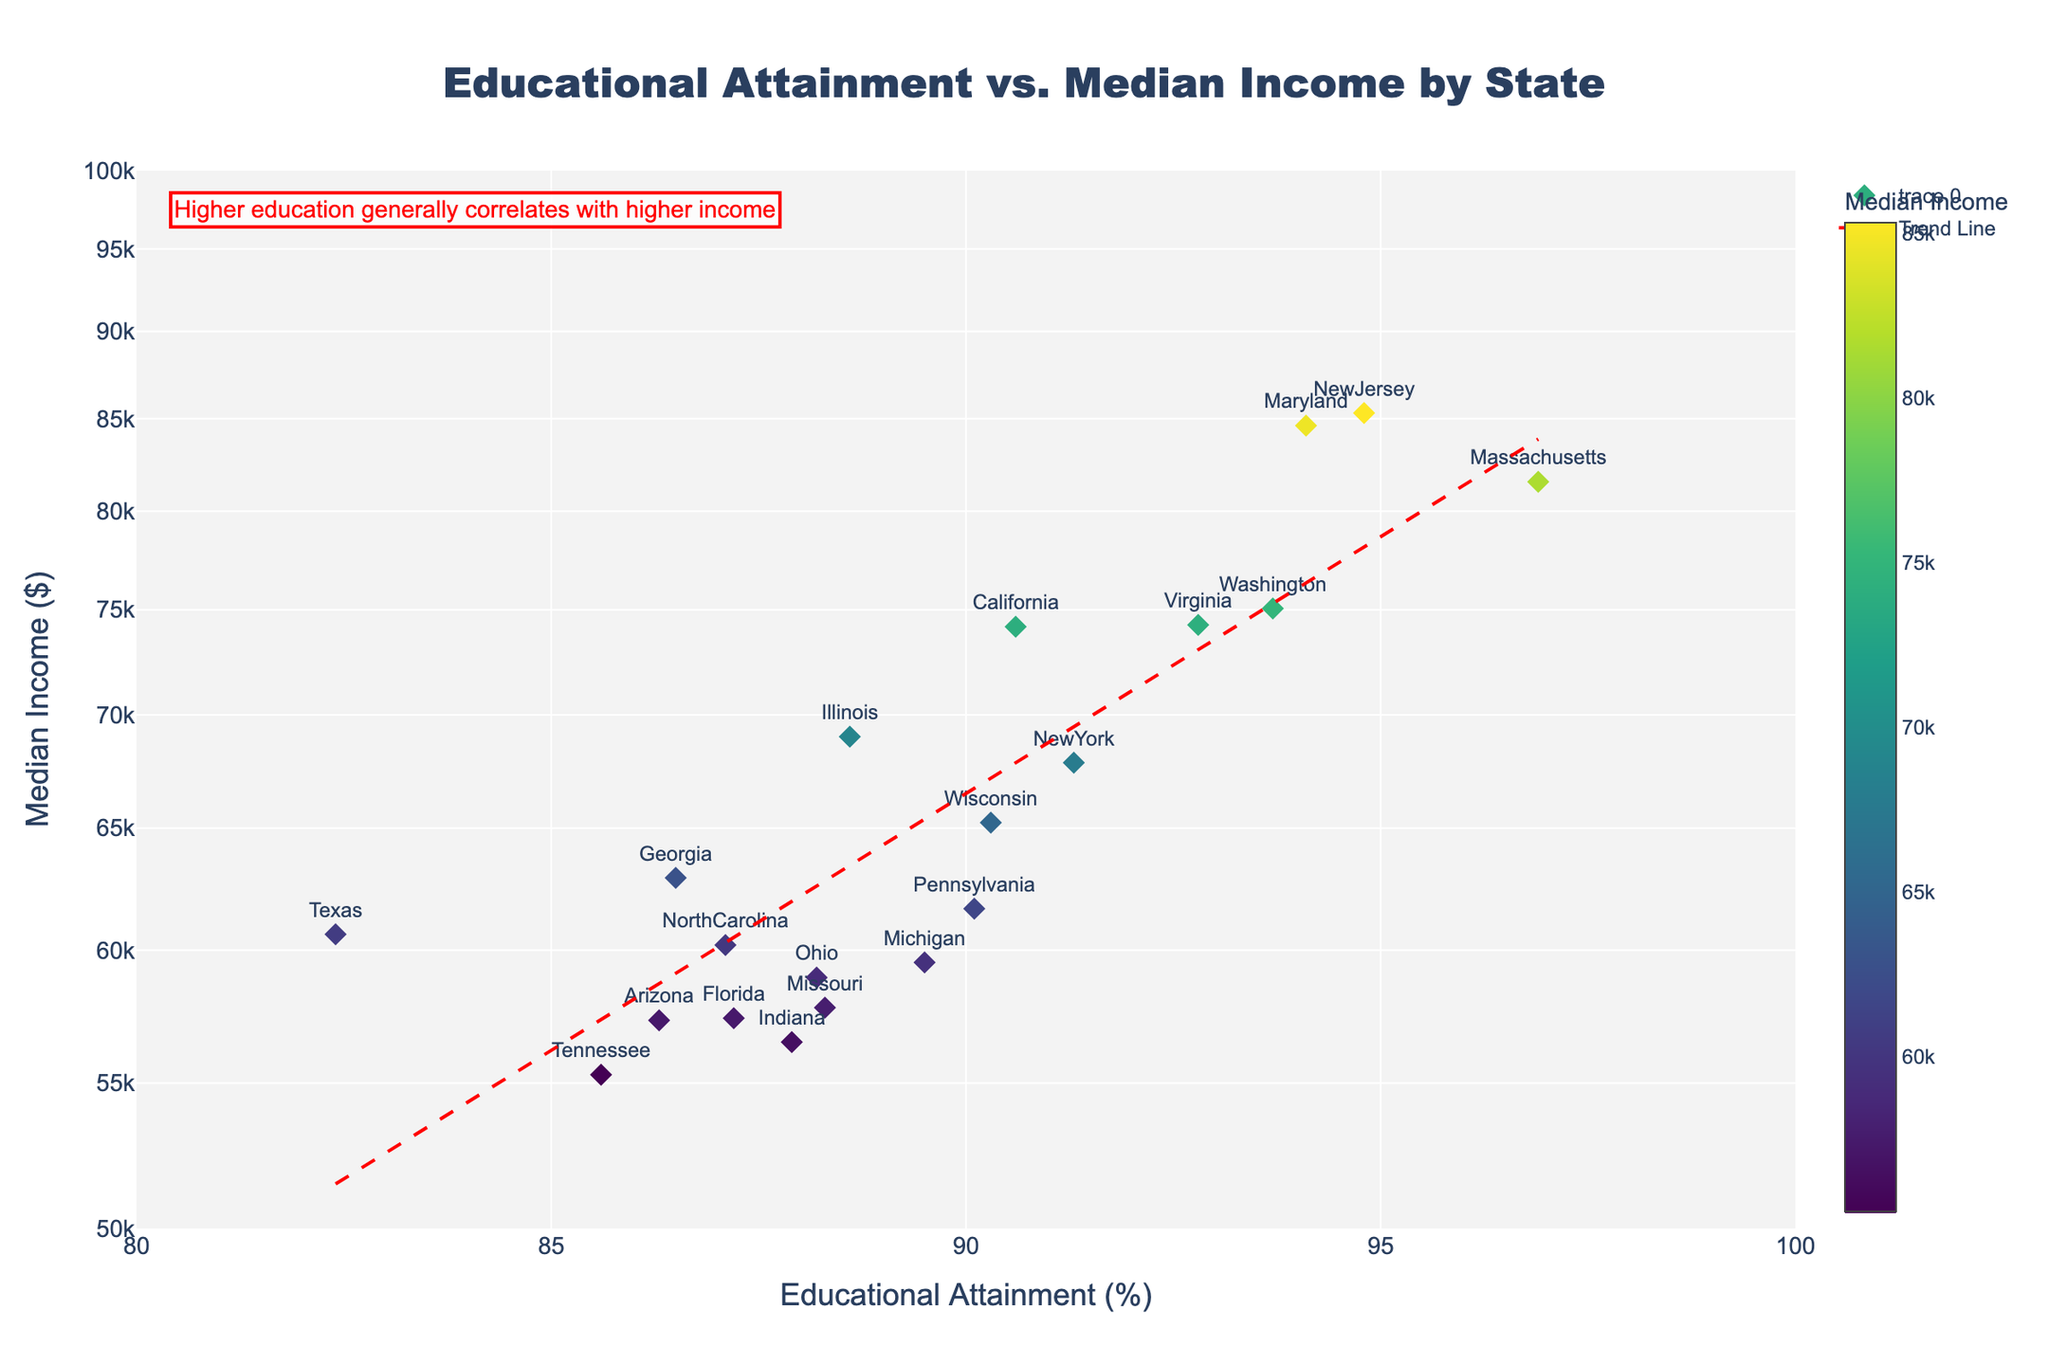What's the title of the figure? The title is usually located at the top of the figure and describes the overall content of the plot.
Answer: Educational Attainment vs. Median Income by State What is the range of the educational attainment axis? By looking at the x-axis, the educational attainment percentage ranges from 80% to 100%.
Answer: 80% to 100% Which state has the highest educational attainment? Find the point on the plot with the highest x-coordinate (rightmost point).
Answer: Massachusetts Which state has the highest median income? Look at the color bar to identify the darkest color, then check the corresponding state.
Answer: New Jersey What trend can you observe between educational attainment and median income? The trend line and annotation suggest that as educational attainment increases, median income also tends to increase.
Answer: Higher educational attainment generally correlates with higher income What's the educational attainment for Texas? Locate the label "Texas" on the plot and read its x-coordinate value.
Answer: 82.4% What is the median income for Florida? Locate the label "Florida" on the plot and read its y-coordinate value.
Answer: $57,388 Which state has the highest educational attainment but lower median income compared to New York? Identify states with higher educational attainment than New York but with lower y-values (median incomes).
Answer: Washington What's the difference in median income between Virginia and Michigan? Subtract the median income of Michigan from that of Virginia. Virginia: $74,253, Michigan: $59,522.
Answer: $14,731 How many states have a median income above $70,000? Count the number of points that lie above the $70,000 mark on the log scale y-axis.
Answer: 5 